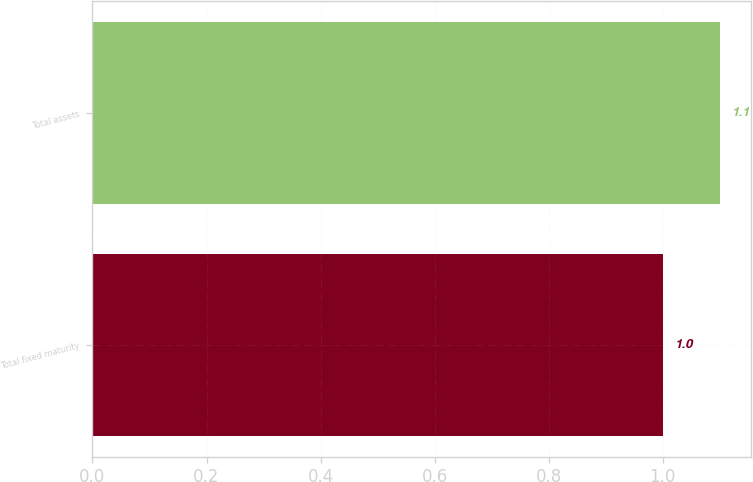Convert chart. <chart><loc_0><loc_0><loc_500><loc_500><bar_chart><fcel>Total fixed maturity<fcel>Total assets<nl><fcel>1<fcel>1.1<nl></chart> 